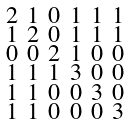<formula> <loc_0><loc_0><loc_500><loc_500>\begin{smallmatrix} 2 & 1 & 0 & 1 & 1 & 1 \\ 1 & 2 & 0 & 1 & 1 & 1 \\ 0 & 0 & 2 & 1 & 0 & 0 \\ 1 & 1 & 1 & 3 & 0 & 0 \\ 1 & 1 & 0 & 0 & 3 & 0 \\ 1 & 1 & 0 & 0 & 0 & 3 \end{smallmatrix}</formula> 